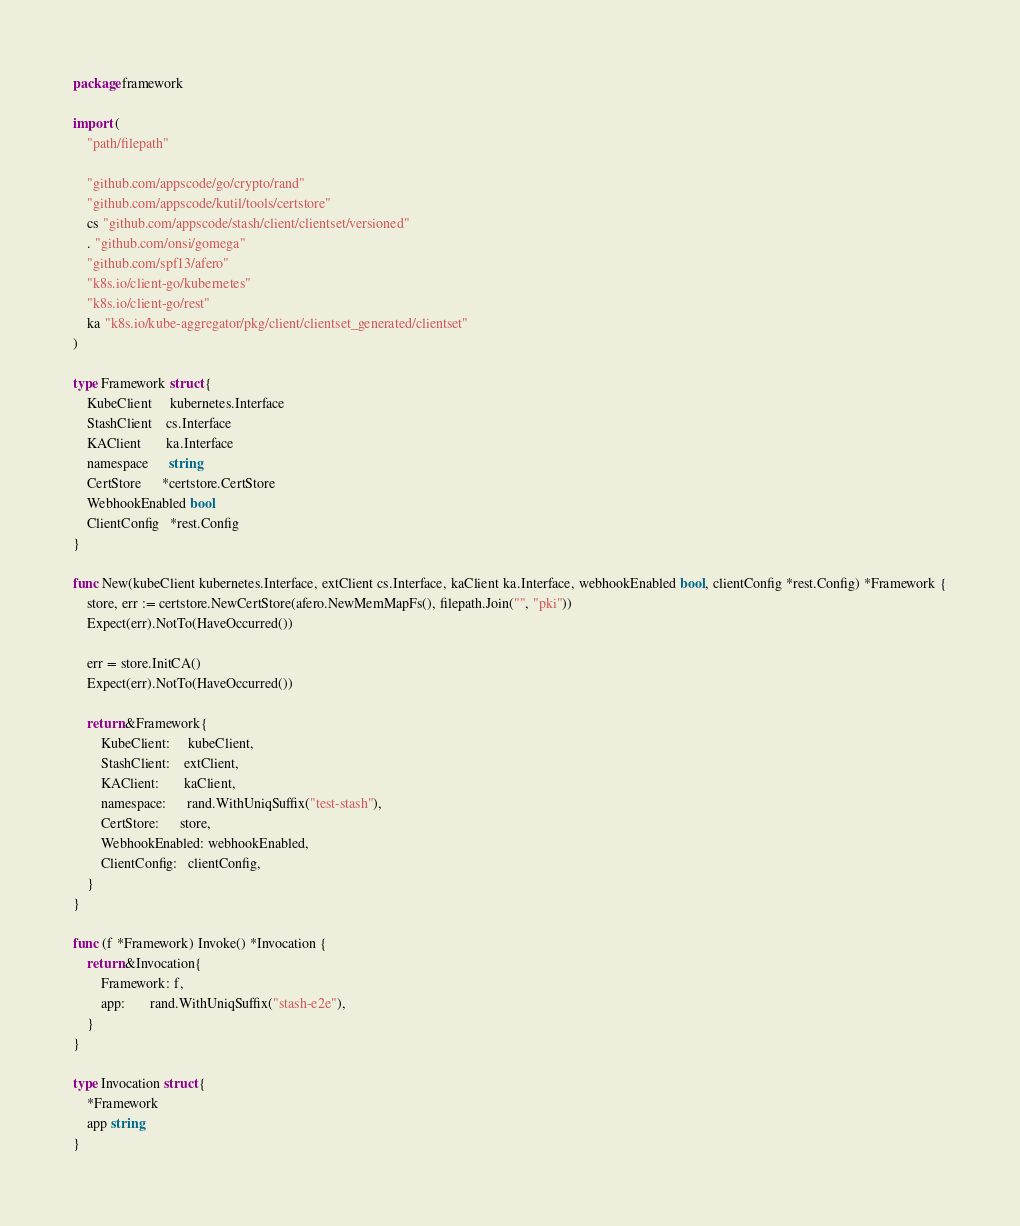Convert code to text. <code><loc_0><loc_0><loc_500><loc_500><_Go_>package framework

import (
	"path/filepath"

	"github.com/appscode/go/crypto/rand"
	"github.com/appscode/kutil/tools/certstore"
	cs "github.com/appscode/stash/client/clientset/versioned"
	. "github.com/onsi/gomega"
	"github.com/spf13/afero"
	"k8s.io/client-go/kubernetes"
	"k8s.io/client-go/rest"
	ka "k8s.io/kube-aggregator/pkg/client/clientset_generated/clientset"
)

type Framework struct {
	KubeClient     kubernetes.Interface
	StashClient    cs.Interface
	KAClient       ka.Interface
	namespace      string
	CertStore      *certstore.CertStore
	WebhookEnabled bool
	ClientConfig   *rest.Config
}

func New(kubeClient kubernetes.Interface, extClient cs.Interface, kaClient ka.Interface, webhookEnabled bool, clientConfig *rest.Config) *Framework {
	store, err := certstore.NewCertStore(afero.NewMemMapFs(), filepath.Join("", "pki"))
	Expect(err).NotTo(HaveOccurred())

	err = store.InitCA()
	Expect(err).NotTo(HaveOccurred())

	return &Framework{
		KubeClient:     kubeClient,
		StashClient:    extClient,
		KAClient:       kaClient,
		namespace:      rand.WithUniqSuffix("test-stash"),
		CertStore:      store,
		WebhookEnabled: webhookEnabled,
		ClientConfig:   clientConfig,
	}
}

func (f *Framework) Invoke() *Invocation {
	return &Invocation{
		Framework: f,
		app:       rand.WithUniqSuffix("stash-e2e"),
	}
}

type Invocation struct {
	*Framework
	app string
}
</code> 